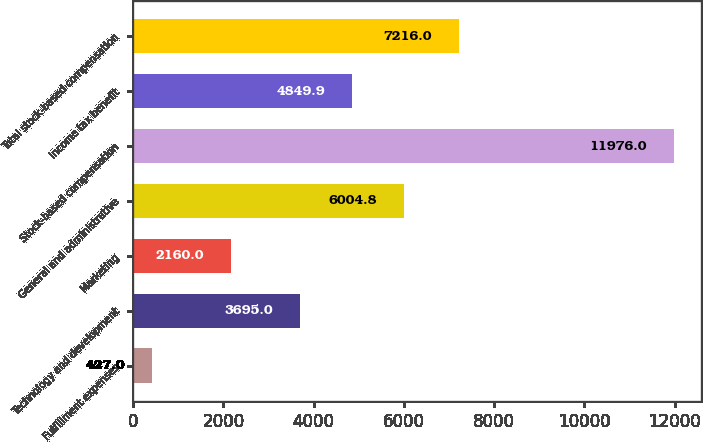Convert chart. <chart><loc_0><loc_0><loc_500><loc_500><bar_chart><fcel>Fulfillment expenses<fcel>Technology and development<fcel>Marketing<fcel>General and administrative<fcel>Stock-based compensation<fcel>Income tax benefit<fcel>Total stock-based compensation<nl><fcel>427<fcel>3695<fcel>2160<fcel>6004.8<fcel>11976<fcel>4849.9<fcel>7216<nl></chart> 